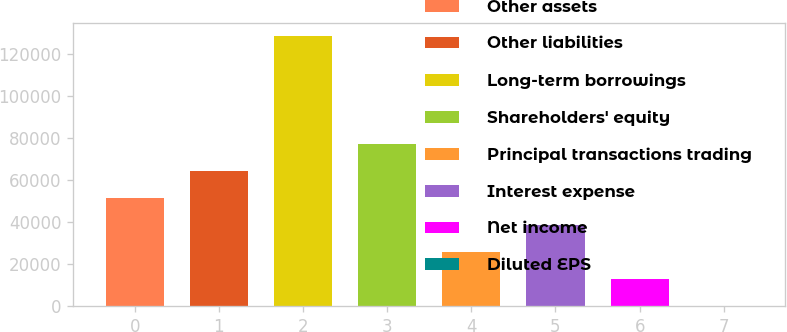<chart> <loc_0><loc_0><loc_500><loc_500><bar_chart><fcel>Other assets<fcel>Other liabilities<fcel>Long-term borrowings<fcel>Shareholders' equity<fcel>Principal transactions trading<fcel>Interest expense<fcel>Net income<fcel>Diluted EPS<nl><fcel>51319.5<fcel>64148.9<fcel>128296<fcel>76978.3<fcel>25660.6<fcel>38490<fcel>12831.2<fcel>1.75<nl></chart> 